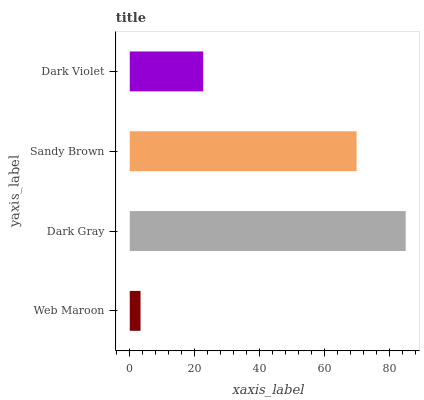Is Web Maroon the minimum?
Answer yes or no. Yes. Is Dark Gray the maximum?
Answer yes or no. Yes. Is Sandy Brown the minimum?
Answer yes or no. No. Is Sandy Brown the maximum?
Answer yes or no. No. Is Dark Gray greater than Sandy Brown?
Answer yes or no. Yes. Is Sandy Brown less than Dark Gray?
Answer yes or no. Yes. Is Sandy Brown greater than Dark Gray?
Answer yes or no. No. Is Dark Gray less than Sandy Brown?
Answer yes or no. No. Is Sandy Brown the high median?
Answer yes or no. Yes. Is Dark Violet the low median?
Answer yes or no. Yes. Is Dark Gray the high median?
Answer yes or no. No. Is Sandy Brown the low median?
Answer yes or no. No. 